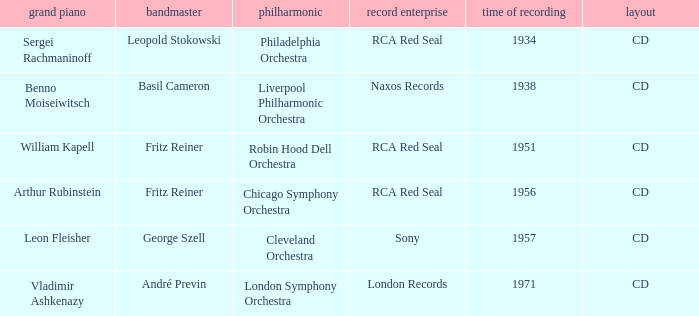Where is the orchestra when the year of recording is 1934? Philadelphia Orchestra. 